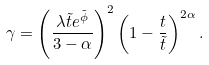Convert formula to latex. <formula><loc_0><loc_0><loc_500><loc_500>\gamma = \left ( \frac { \lambda \tilde { t } e ^ { \tilde { \phi } } } { 3 - \alpha } \right ) ^ { 2 } \left ( 1 - \frac { t } { \tilde { t } } \right ) ^ { 2 \alpha } .</formula> 